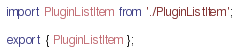Convert code to text. <code><loc_0><loc_0><loc_500><loc_500><_JavaScript_>import PluginListItem from './PluginListItem';

export { PluginListItem };
</code> 